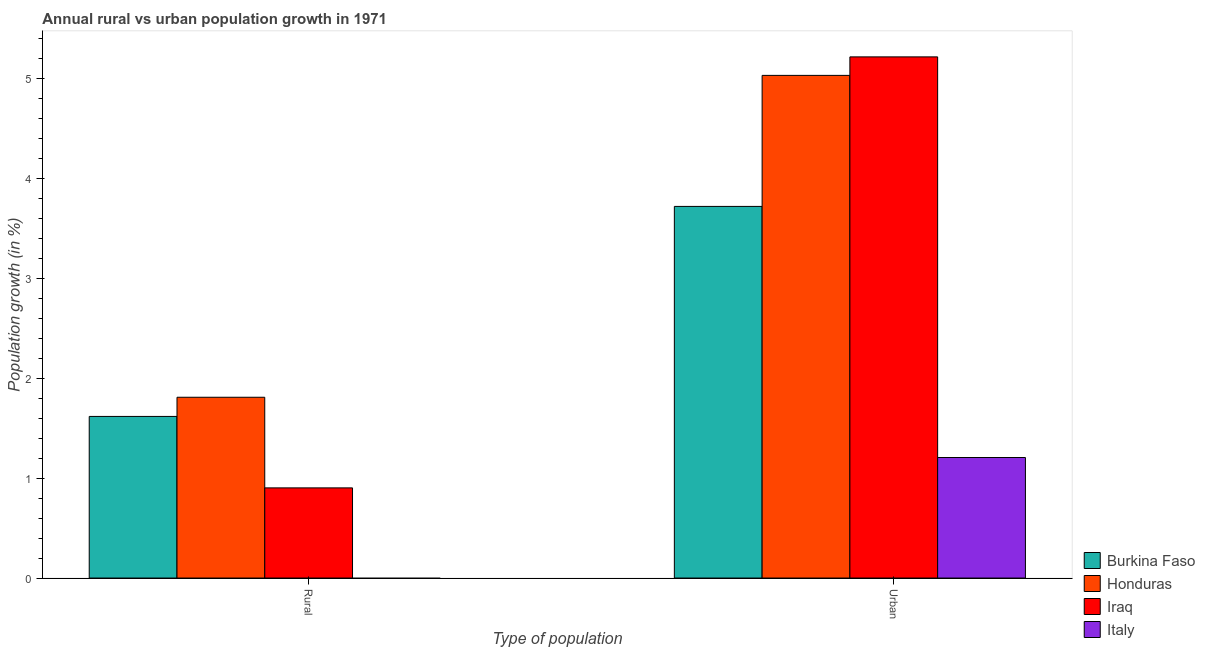How many different coloured bars are there?
Offer a terse response. 4. How many groups of bars are there?
Make the answer very short. 2. Are the number of bars per tick equal to the number of legend labels?
Your response must be concise. No. Are the number of bars on each tick of the X-axis equal?
Ensure brevity in your answer.  No. How many bars are there on the 1st tick from the left?
Offer a very short reply. 3. What is the label of the 2nd group of bars from the left?
Provide a short and direct response. Urban . What is the rural population growth in Burkina Faso?
Your response must be concise. 1.62. Across all countries, what is the maximum rural population growth?
Ensure brevity in your answer.  1.81. Across all countries, what is the minimum rural population growth?
Your answer should be compact. 0. In which country was the rural population growth maximum?
Keep it short and to the point. Honduras. What is the total rural population growth in the graph?
Offer a very short reply. 4.33. What is the difference between the rural population growth in Burkina Faso and that in Iraq?
Your response must be concise. 0.72. What is the difference between the urban population growth in Burkina Faso and the rural population growth in Italy?
Make the answer very short. 3.72. What is the average urban population growth per country?
Your answer should be compact. 3.8. What is the difference between the urban population growth and rural population growth in Burkina Faso?
Provide a short and direct response. 2.1. What is the ratio of the urban population growth in Burkina Faso to that in Iraq?
Your response must be concise. 0.71. In how many countries, is the urban population growth greater than the average urban population growth taken over all countries?
Keep it short and to the point. 2. How many bars are there?
Ensure brevity in your answer.  7. How many countries are there in the graph?
Your answer should be compact. 4. What is the difference between two consecutive major ticks on the Y-axis?
Make the answer very short. 1. Are the values on the major ticks of Y-axis written in scientific E-notation?
Give a very brief answer. No. Does the graph contain any zero values?
Your answer should be compact. Yes. Where does the legend appear in the graph?
Ensure brevity in your answer.  Bottom right. How many legend labels are there?
Give a very brief answer. 4. How are the legend labels stacked?
Give a very brief answer. Vertical. What is the title of the graph?
Give a very brief answer. Annual rural vs urban population growth in 1971. What is the label or title of the X-axis?
Make the answer very short. Type of population. What is the label or title of the Y-axis?
Give a very brief answer. Population growth (in %). What is the Population growth (in %) of Burkina Faso in Rural?
Your response must be concise. 1.62. What is the Population growth (in %) in Honduras in Rural?
Give a very brief answer. 1.81. What is the Population growth (in %) in Iraq in Rural?
Your answer should be very brief. 0.9. What is the Population growth (in %) of Burkina Faso in Urban ?
Provide a succinct answer. 3.72. What is the Population growth (in %) in Honduras in Urban ?
Keep it short and to the point. 5.04. What is the Population growth (in %) of Iraq in Urban ?
Ensure brevity in your answer.  5.22. What is the Population growth (in %) in Italy in Urban ?
Offer a terse response. 1.21. Across all Type of population, what is the maximum Population growth (in %) of Burkina Faso?
Make the answer very short. 3.72. Across all Type of population, what is the maximum Population growth (in %) of Honduras?
Your answer should be very brief. 5.04. Across all Type of population, what is the maximum Population growth (in %) of Iraq?
Your answer should be very brief. 5.22. Across all Type of population, what is the maximum Population growth (in %) in Italy?
Your answer should be very brief. 1.21. Across all Type of population, what is the minimum Population growth (in %) of Burkina Faso?
Provide a succinct answer. 1.62. Across all Type of population, what is the minimum Population growth (in %) of Honduras?
Your answer should be compact. 1.81. Across all Type of population, what is the minimum Population growth (in %) of Iraq?
Provide a succinct answer. 0.9. Across all Type of population, what is the minimum Population growth (in %) in Italy?
Offer a terse response. 0. What is the total Population growth (in %) in Burkina Faso in the graph?
Keep it short and to the point. 5.34. What is the total Population growth (in %) of Honduras in the graph?
Offer a terse response. 6.85. What is the total Population growth (in %) of Iraq in the graph?
Make the answer very short. 6.12. What is the total Population growth (in %) in Italy in the graph?
Provide a short and direct response. 1.21. What is the difference between the Population growth (in %) of Burkina Faso in Rural and that in Urban ?
Your answer should be compact. -2.1. What is the difference between the Population growth (in %) in Honduras in Rural and that in Urban ?
Provide a short and direct response. -3.22. What is the difference between the Population growth (in %) in Iraq in Rural and that in Urban ?
Your answer should be compact. -4.32. What is the difference between the Population growth (in %) of Burkina Faso in Rural and the Population growth (in %) of Honduras in Urban?
Give a very brief answer. -3.42. What is the difference between the Population growth (in %) in Burkina Faso in Rural and the Population growth (in %) in Iraq in Urban?
Provide a succinct answer. -3.6. What is the difference between the Population growth (in %) of Burkina Faso in Rural and the Population growth (in %) of Italy in Urban?
Offer a very short reply. 0.41. What is the difference between the Population growth (in %) in Honduras in Rural and the Population growth (in %) in Iraq in Urban?
Ensure brevity in your answer.  -3.41. What is the difference between the Population growth (in %) of Honduras in Rural and the Population growth (in %) of Italy in Urban?
Give a very brief answer. 0.6. What is the difference between the Population growth (in %) of Iraq in Rural and the Population growth (in %) of Italy in Urban?
Make the answer very short. -0.3. What is the average Population growth (in %) in Burkina Faso per Type of population?
Your answer should be very brief. 2.67. What is the average Population growth (in %) in Honduras per Type of population?
Offer a very short reply. 3.42. What is the average Population growth (in %) of Iraq per Type of population?
Provide a short and direct response. 3.06. What is the average Population growth (in %) of Italy per Type of population?
Offer a very short reply. 0.6. What is the difference between the Population growth (in %) of Burkina Faso and Population growth (in %) of Honduras in Rural?
Make the answer very short. -0.19. What is the difference between the Population growth (in %) of Burkina Faso and Population growth (in %) of Iraq in Rural?
Offer a terse response. 0.72. What is the difference between the Population growth (in %) in Honduras and Population growth (in %) in Iraq in Rural?
Make the answer very short. 0.91. What is the difference between the Population growth (in %) of Burkina Faso and Population growth (in %) of Honduras in Urban ?
Keep it short and to the point. -1.31. What is the difference between the Population growth (in %) in Burkina Faso and Population growth (in %) in Iraq in Urban ?
Provide a succinct answer. -1.5. What is the difference between the Population growth (in %) in Burkina Faso and Population growth (in %) in Italy in Urban ?
Your answer should be compact. 2.52. What is the difference between the Population growth (in %) in Honduras and Population growth (in %) in Iraq in Urban ?
Ensure brevity in your answer.  -0.19. What is the difference between the Population growth (in %) in Honduras and Population growth (in %) in Italy in Urban ?
Your response must be concise. 3.83. What is the difference between the Population growth (in %) in Iraq and Population growth (in %) in Italy in Urban ?
Ensure brevity in your answer.  4.01. What is the ratio of the Population growth (in %) of Burkina Faso in Rural to that in Urban ?
Your answer should be compact. 0.43. What is the ratio of the Population growth (in %) in Honduras in Rural to that in Urban ?
Provide a succinct answer. 0.36. What is the ratio of the Population growth (in %) of Iraq in Rural to that in Urban ?
Make the answer very short. 0.17. What is the difference between the highest and the second highest Population growth (in %) in Burkina Faso?
Provide a short and direct response. 2.1. What is the difference between the highest and the second highest Population growth (in %) of Honduras?
Provide a succinct answer. 3.22. What is the difference between the highest and the second highest Population growth (in %) of Iraq?
Make the answer very short. 4.32. What is the difference between the highest and the lowest Population growth (in %) in Burkina Faso?
Provide a short and direct response. 2.1. What is the difference between the highest and the lowest Population growth (in %) in Honduras?
Provide a succinct answer. 3.22. What is the difference between the highest and the lowest Population growth (in %) in Iraq?
Ensure brevity in your answer.  4.32. What is the difference between the highest and the lowest Population growth (in %) of Italy?
Offer a very short reply. 1.21. 